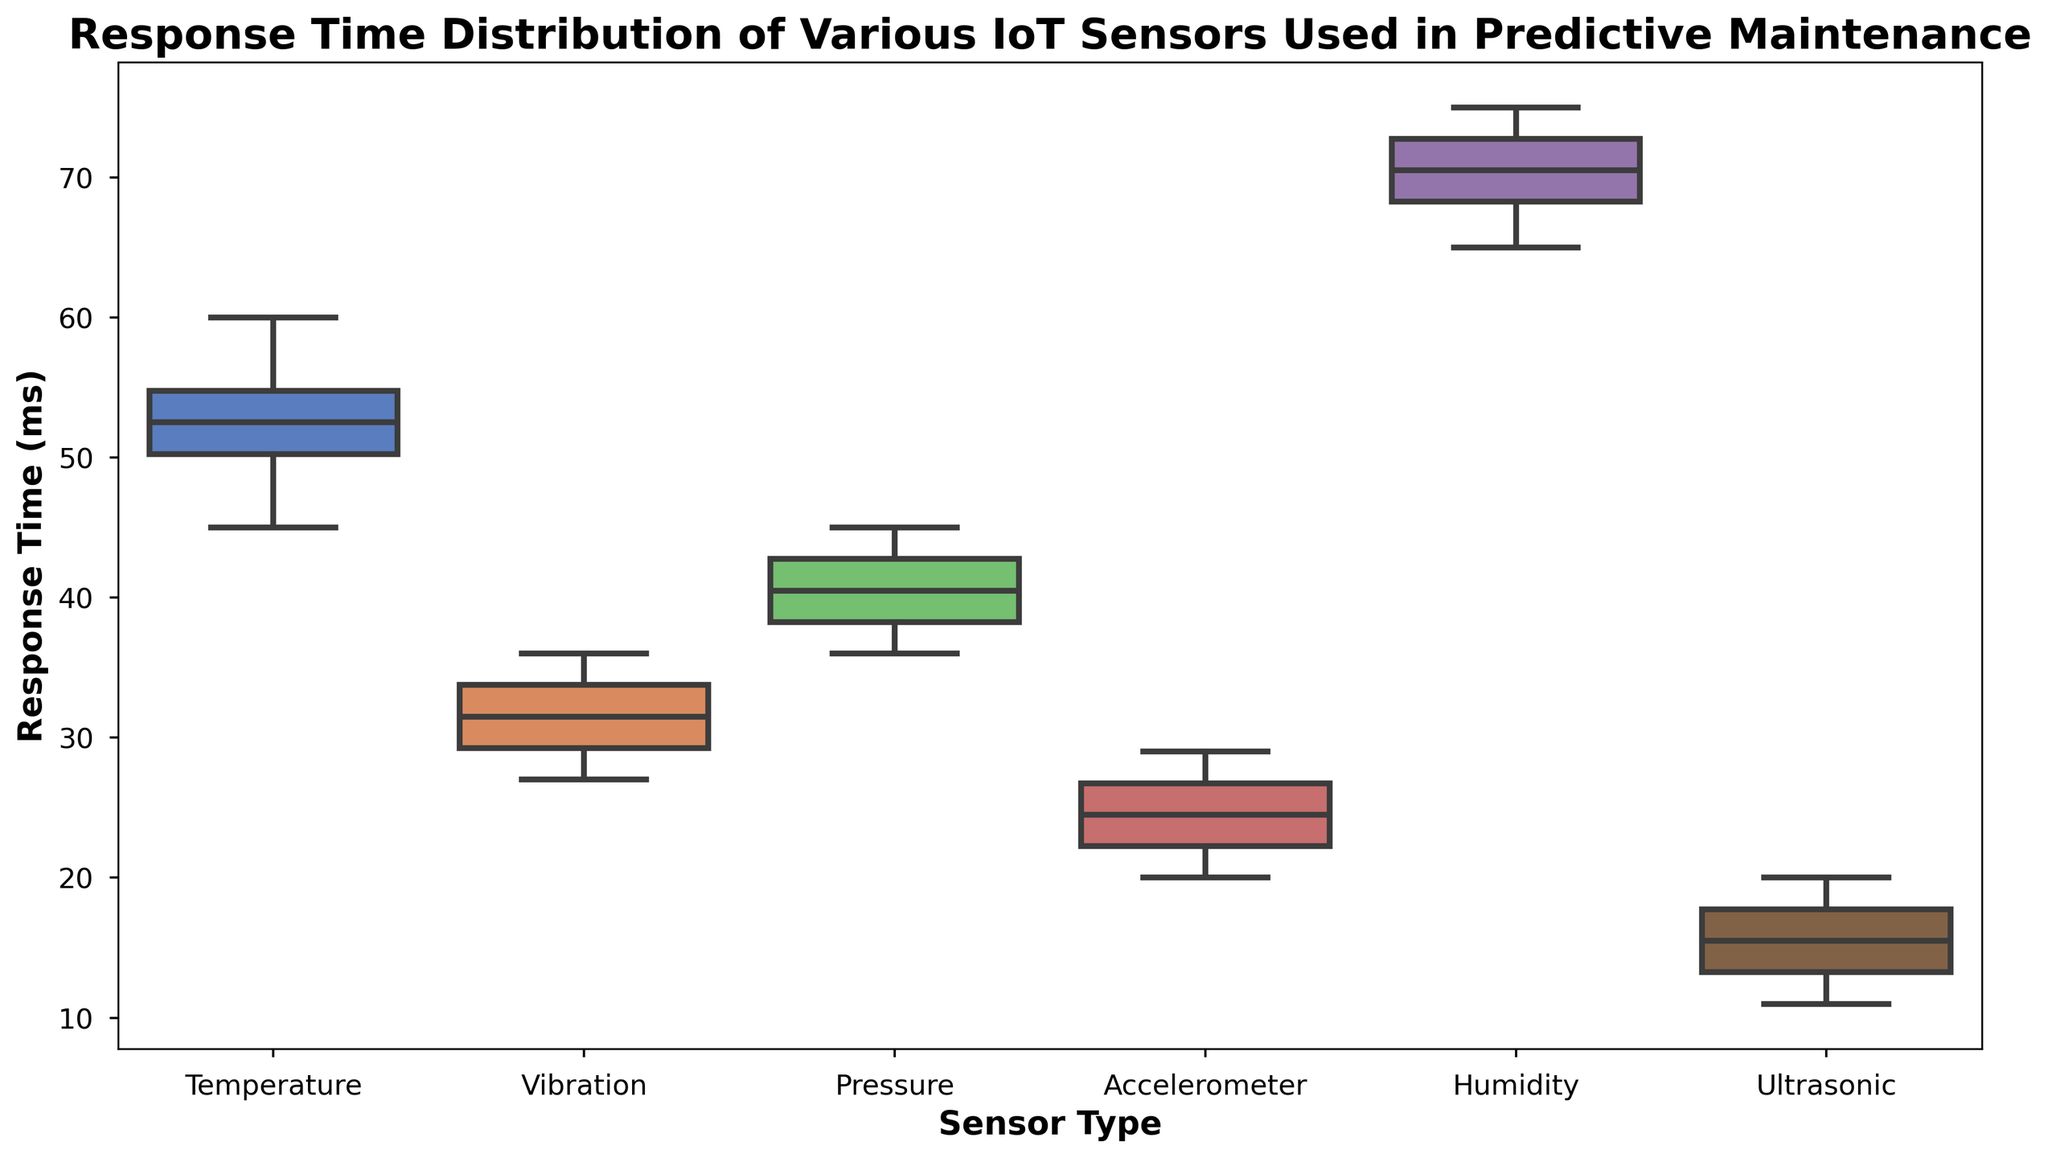Which sensor type shows the widest range of response times? To determine the sensor type with the widest range of response times, look for the sensor whose box plot extends over the largest distance on the y-axis. This indicates a large interquartile range (IQR), suggesting greater variability in response times. The Humidity sensor box plot is the longest, indicating the widest range.
Answer: Humidity Which sensor type has the smallest median response time? The median is the central line inside each box in the box plot. Compare the positions of these lines across the sensor types. The Ultrasonic sensor has the lowest median line, indicating the smallest median response time.
Answer: Ultrasonic What is the interquartile range (IQR) for the Temperature sensor? The IQR is the difference between the first quartile (Q1) and the third quartile (Q3). In the box plot, Q1 is the bottom edge of the box, and Q3 is the top edge of the box. For the Temperature sensor, visually estimate these values and subtract Q1 from Q3. If Q1 is around 48 ms and Q3 is around 55 ms, then IQR = 55 - 48 = 7 ms.
Answer: 7 ms How does the variability in response time of the Vibration sensor compare to the Pressure sensor? Variability can be assessed by comparing the lengths of the boxes (IQR) and the overall spread of the whiskers. The box of the Vibration sensor is shorter than that of the Pressure sensor, indicating less variability in response times for the Vibration sensor.
Answer: Less variable Is the response time of the Accelerometer sensor more consistent than the Humidity sensor? Consistency can be judged by the length of the box (IQR) and how tightly grouped the whiskers and outliers are. The Accelerometer sensor has a much shorter box compared to the Humidity sensor, indicating more consistent response times.
Answer: Yes Which sensor has the highest upper whisker value, indicating the maximum non-outlier response time? The upper whisker extends from the top of the box to the highest value within 1.5 times the IQR from the third quartile (Q3). Look for the sensor with the highest extending whisker. The Humidity sensor has the highest upper whisker.
Answer: Humidity Considering the range and median, which sensor type would you consider most reliable in terms of predictability of response times? A reliable sensor would have a smaller range (indicating less variability) and a lower median response time. The Ultrasonic sensor has a small range and the lowest median response time, suggesting high predictability and reliability.
Answer: Ultrasonic What is the difference between the median response times of the Pressure and Temperature sensors? Locate the median lines for both the Pressure and Temperature sensors in their respective boxes. Subtract the median response time of the Pressure sensor from that of the Temperature sensor. If the median for Pressure is around 40 ms and for Temperature is around 53 ms, the difference is 53 - 40 = 13 ms.
Answer: 13 ms Do any sensor types have outliers significantly lower than the rest of the data? Outliers are represented as individual points outside the whiskers in a box plot. If these points fall significantly lower than the minimum whisker value, they are considered significant. The Ultrasonic sensor has low outlier points below its lower whisker.
Answer: Yes 